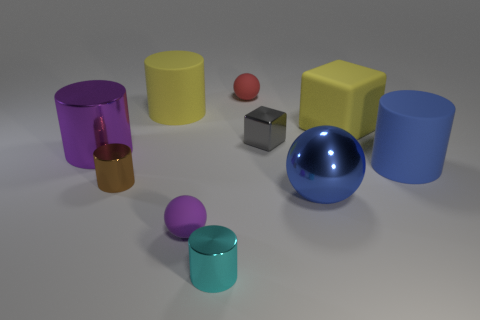How many other things are there of the same size as the cyan metal thing?
Your response must be concise. 4. Is the size of the rubber sphere that is behind the brown object the same as the yellow matte thing on the left side of the big metal sphere?
Provide a succinct answer. No. What is the material of the big blue thing in front of the large matte thing in front of the big purple shiny cylinder?
Keep it short and to the point. Metal. How many things are matte balls in front of the purple shiny thing or green things?
Make the answer very short. 1. Is the number of tiny cyan metallic cylinders that are on the right side of the big blue matte object the same as the number of large blue metal things that are behind the red rubber sphere?
Provide a succinct answer. Yes. What is the material of the large cylinder on the right side of the big metal thing to the right of the purple metallic cylinder left of the small red matte ball?
Keep it short and to the point. Rubber. There is a rubber thing that is both left of the big yellow matte cube and in front of the tiny block; what is its size?
Make the answer very short. Small. Is the small purple object the same shape as the red thing?
Keep it short and to the point. Yes. There is a large thing that is the same material as the large purple cylinder; what is its shape?
Make the answer very short. Sphere. How many tiny things are things or gray objects?
Ensure brevity in your answer.  5. 